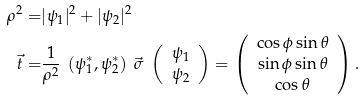<formula> <loc_0><loc_0><loc_500><loc_500>\rho ^ { 2 } = & | \psi _ { 1 } | ^ { 2 } + | \psi _ { 2 } | ^ { 2 } \\ \vec { t } = & \frac { 1 } { \rho ^ { 2 } } \ \left ( \psi ^ { * } _ { 1 } , \psi ^ { * } _ { 2 } \right ) \ \vec { \sigma } \ \left ( \begin{array} { c } \psi _ { 1 } \\ \psi _ { 2 } \end{array} \right ) = \left ( \begin{array} { c } \cos \phi \sin \theta \\ \sin \phi \sin \theta \\ \cos \theta \end{array} \right ) .</formula> 